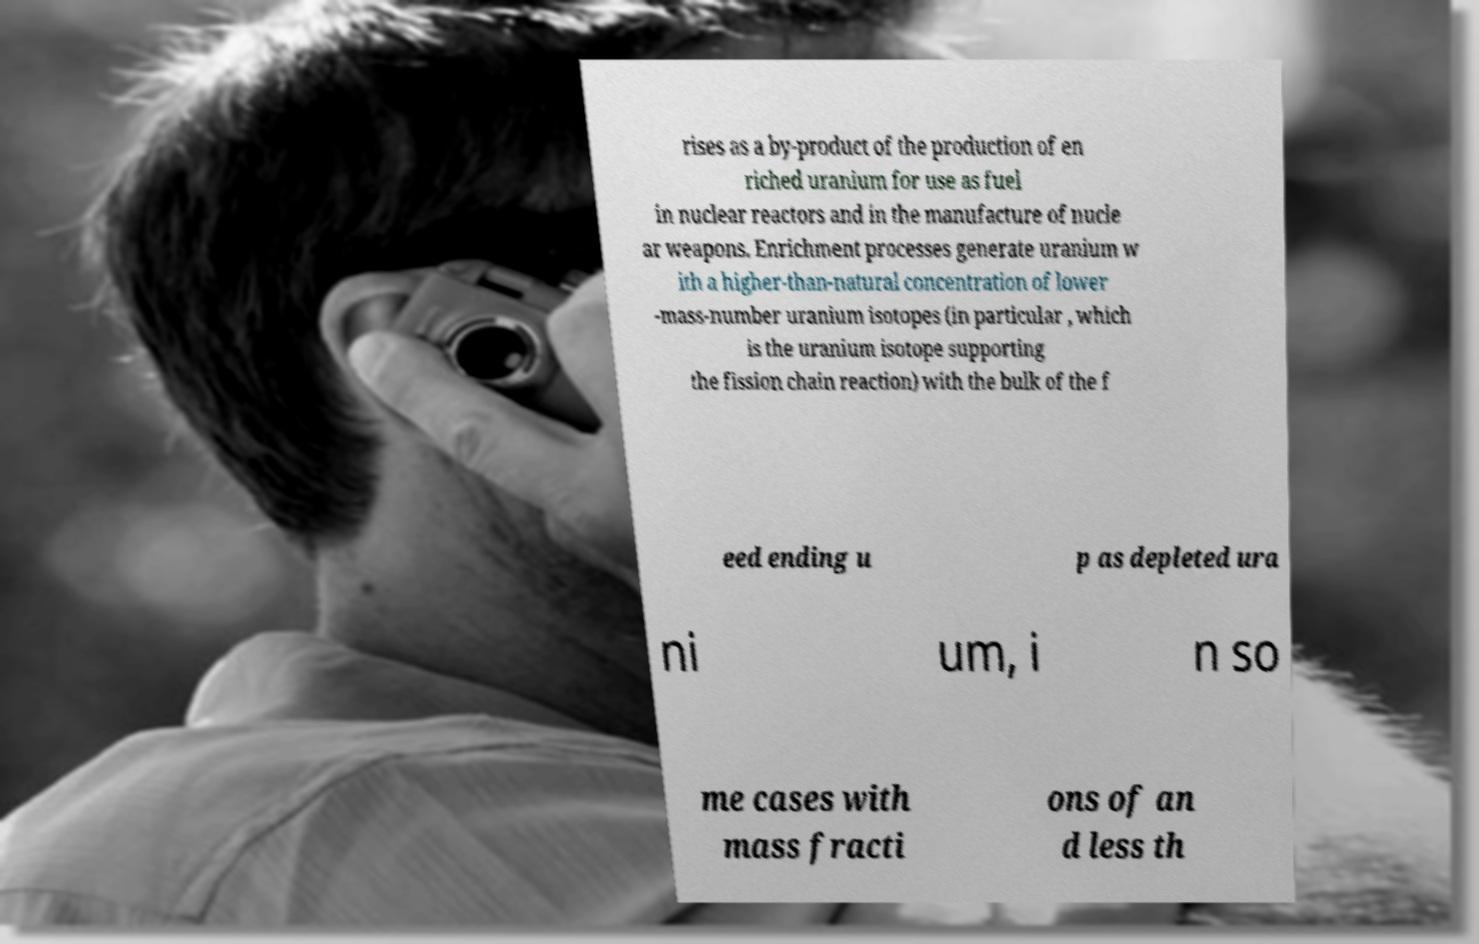Could you extract and type out the text from this image? rises as a by-product of the production of en riched uranium for use as fuel in nuclear reactors and in the manufacture of nucle ar weapons. Enrichment processes generate uranium w ith a higher-than-natural concentration of lower -mass-number uranium isotopes (in particular , which is the uranium isotope supporting the fission chain reaction) with the bulk of the f eed ending u p as depleted ura ni um, i n so me cases with mass fracti ons of an d less th 